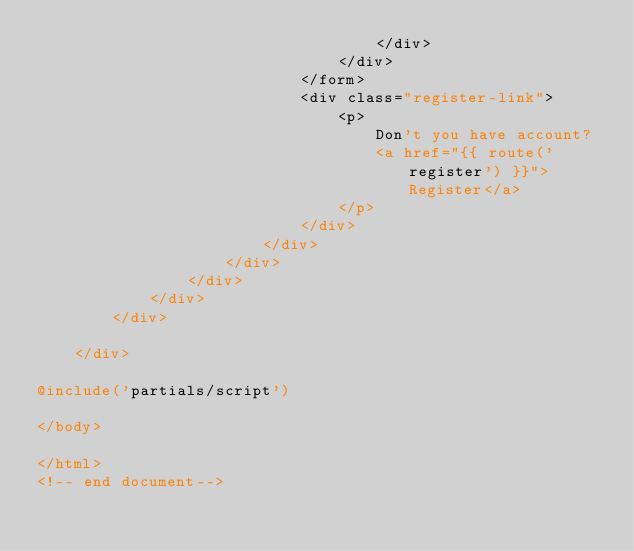<code> <loc_0><loc_0><loc_500><loc_500><_PHP_>                                    </div>
                                </div>
                            </form>
                            <div class="register-link">
                                <p>
                                    Don't you have account?
                                    <a href="{{ route('register') }}">Register</a>
                                </p>
                            </div>
                        </div>
                    </div>
                </div>
            </div>
        </div>

    </div>

@include('partials/script')

</body>

</html>
<!-- end document--></code> 